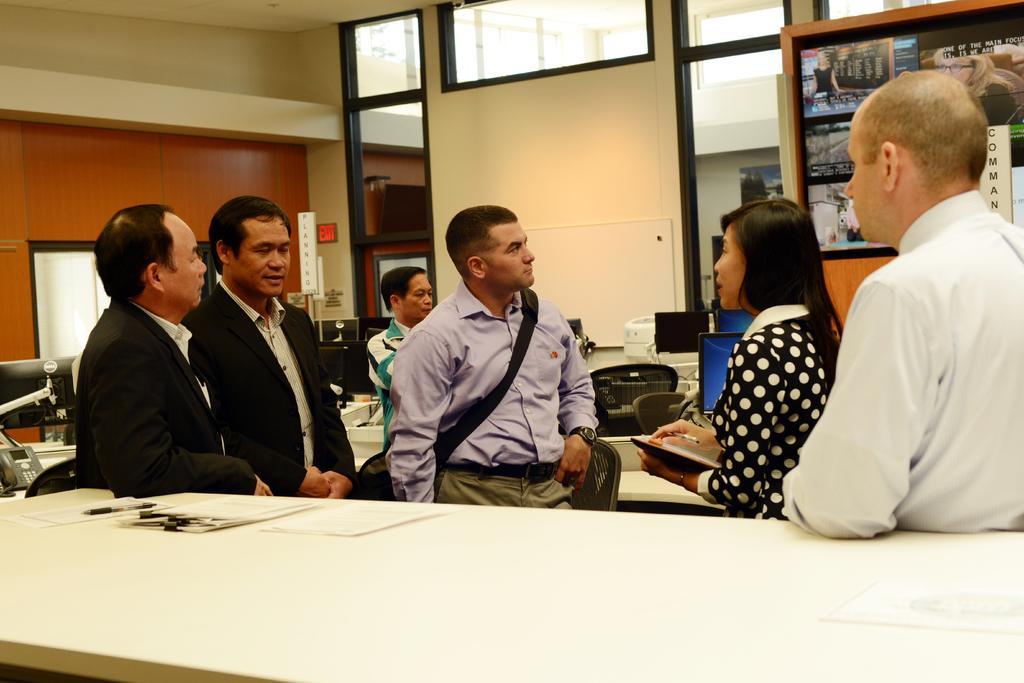Could you give a brief overview of what you see in this image? In this image, we can see a group of people. Here a woman is holding a book and pen. At the bottom, there is a white table. Few papers are placed on it. Background we can see few monitors, screen, objects, telephone, chairs, wall, boards, glass and sign board. 